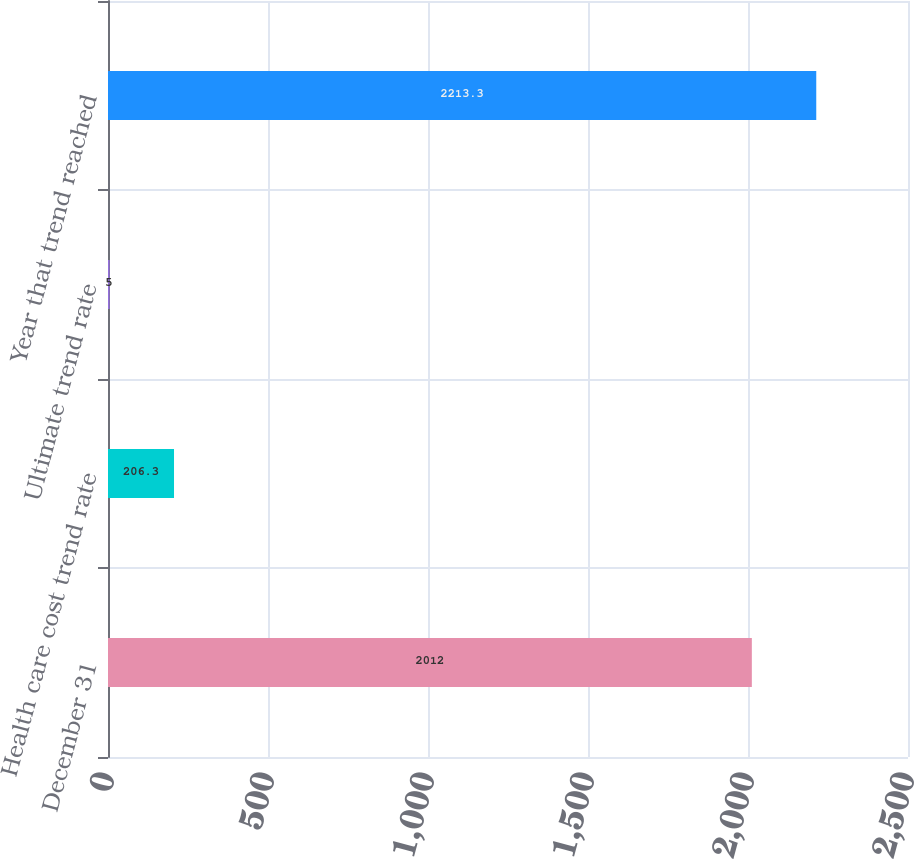<chart> <loc_0><loc_0><loc_500><loc_500><bar_chart><fcel>December 31<fcel>Health care cost trend rate<fcel>Ultimate trend rate<fcel>Year that trend reached<nl><fcel>2012<fcel>206.3<fcel>5<fcel>2213.3<nl></chart> 